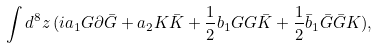Convert formula to latex. <formula><loc_0><loc_0><loc_500><loc_500>\int d ^ { 8 } z \, ( i a _ { 1 } G \partial \bar { G } + a _ { 2 } K \bar { K } + { \frac { 1 } { 2 } } b _ { 1 } G G \bar { K } + { \frac { 1 } { 2 } } \bar { b } _ { 1 } \bar { G } \bar { G } K ) ,</formula> 